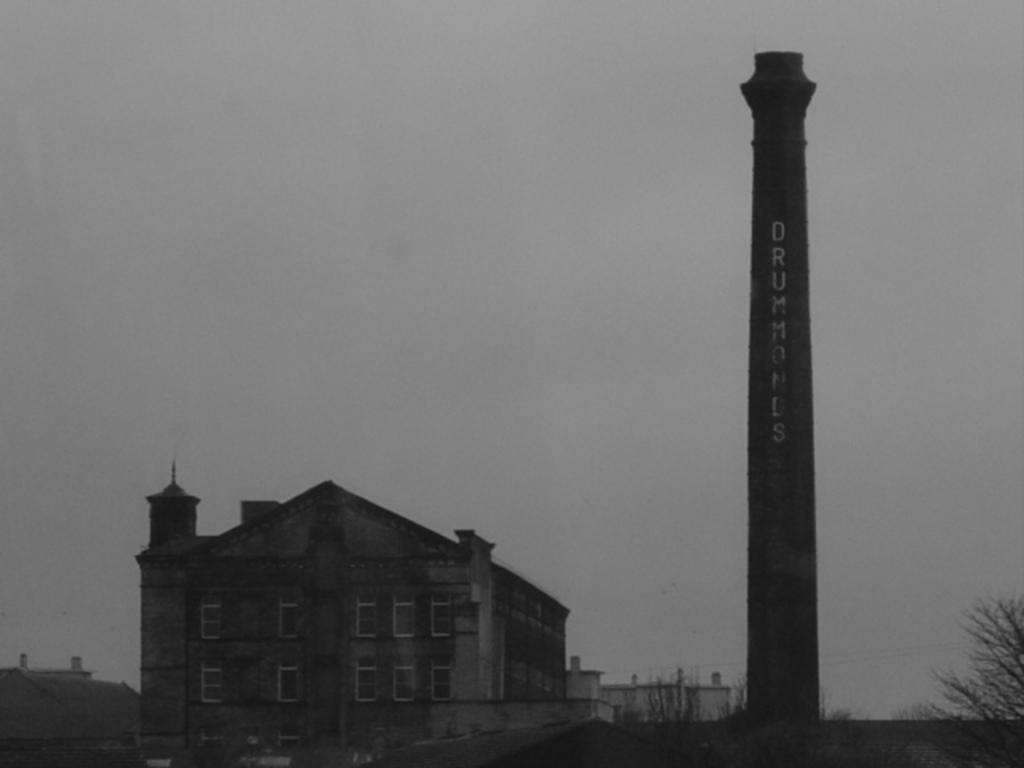What type of structures are present in the image? There are buildings and a tower in the image. Can you describe the tower's location in relation to the buildings? The tower is beside the buildings in the image. What can be seen in the right corner of the image? There is a tree with no leaves in the right corner of the image. What type of stage is visible in the image? There is no stage present in the image. How many wheels can be seen on the tower in the image? There are no wheels visible on the tower in the image. 